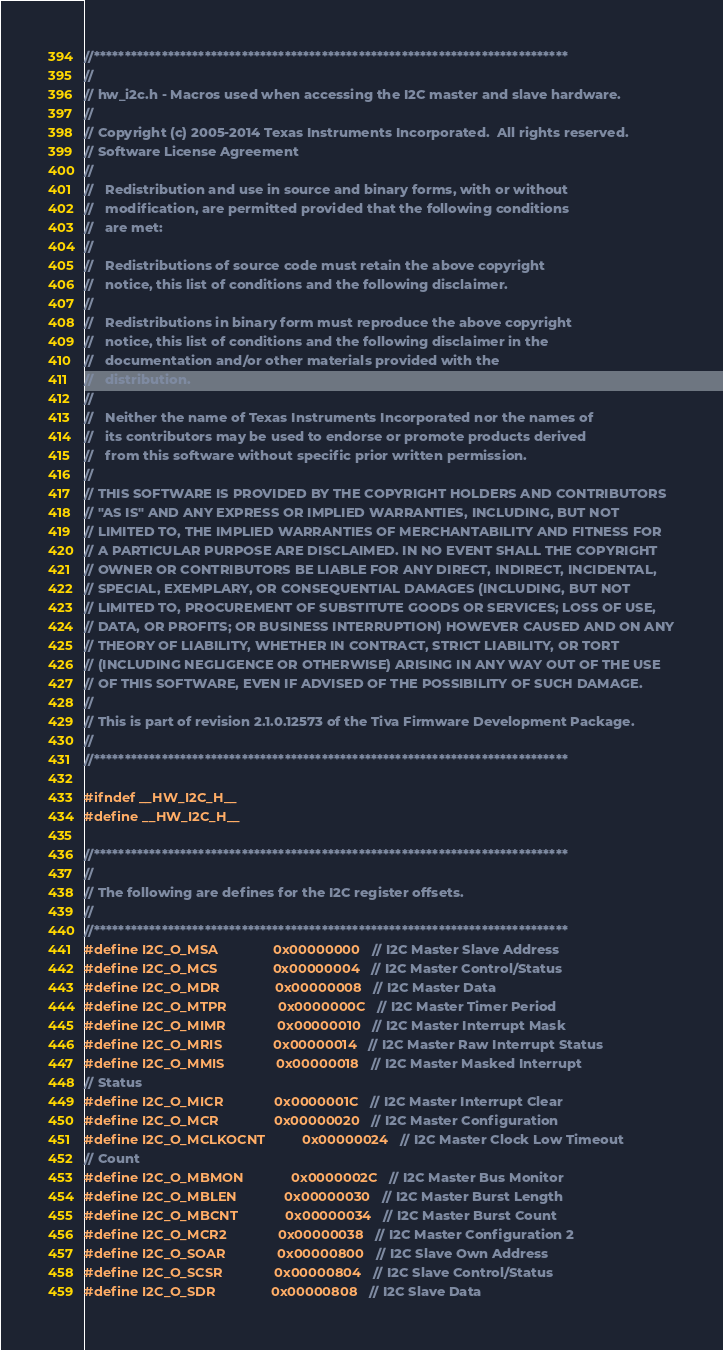<code> <loc_0><loc_0><loc_500><loc_500><_C_>//*****************************************************************************
//
// hw_i2c.h - Macros used when accessing the I2C master and slave hardware.
//
// Copyright (c) 2005-2014 Texas Instruments Incorporated.  All rights reserved.
// Software License Agreement
//
//   Redistribution and use in source and binary forms, with or without
//   modification, are permitted provided that the following conditions
//   are met:
//
//   Redistributions of source code must retain the above copyright
//   notice, this list of conditions and the following disclaimer.
//
//   Redistributions in binary form must reproduce the above copyright
//   notice, this list of conditions and the following disclaimer in the
//   documentation and/or other materials provided with the
//   distribution.
//
//   Neither the name of Texas Instruments Incorporated nor the names of
//   its contributors may be used to endorse or promote products derived
//   from this software without specific prior written permission.
//
// THIS SOFTWARE IS PROVIDED BY THE COPYRIGHT HOLDERS AND CONTRIBUTORS
// "AS IS" AND ANY EXPRESS OR IMPLIED WARRANTIES, INCLUDING, BUT NOT
// LIMITED TO, THE IMPLIED WARRANTIES OF MERCHANTABILITY AND FITNESS FOR
// A PARTICULAR PURPOSE ARE DISCLAIMED. IN NO EVENT SHALL THE COPYRIGHT
// OWNER OR CONTRIBUTORS BE LIABLE FOR ANY DIRECT, INDIRECT, INCIDENTAL,
// SPECIAL, EXEMPLARY, OR CONSEQUENTIAL DAMAGES (INCLUDING, BUT NOT
// LIMITED TO, PROCUREMENT OF SUBSTITUTE GOODS OR SERVICES; LOSS OF USE,
// DATA, OR PROFITS; OR BUSINESS INTERRUPTION) HOWEVER CAUSED AND ON ANY
// THEORY OF LIABILITY, WHETHER IN CONTRACT, STRICT LIABILITY, OR TORT
// (INCLUDING NEGLIGENCE OR OTHERWISE) ARISING IN ANY WAY OUT OF THE USE
// OF THIS SOFTWARE, EVEN IF ADVISED OF THE POSSIBILITY OF SUCH DAMAGE.
//
// This is part of revision 2.1.0.12573 of the Tiva Firmware Development Package.
//
//*****************************************************************************

#ifndef __HW_I2C_H__
#define __HW_I2C_H__

//*****************************************************************************
//
// The following are defines for the I2C register offsets.
//
//*****************************************************************************
#define I2C_O_MSA               0x00000000  // I2C Master Slave Address
#define I2C_O_MCS               0x00000004  // I2C Master Control/Status
#define I2C_O_MDR               0x00000008  // I2C Master Data
#define I2C_O_MTPR              0x0000000C  // I2C Master Timer Period
#define I2C_O_MIMR              0x00000010  // I2C Master Interrupt Mask
#define I2C_O_MRIS              0x00000014  // I2C Master Raw Interrupt Status
#define I2C_O_MMIS              0x00000018  // I2C Master Masked Interrupt
// Status
#define I2C_O_MICR              0x0000001C  // I2C Master Interrupt Clear
#define I2C_O_MCR               0x00000020  // I2C Master Configuration
#define I2C_O_MCLKOCNT          0x00000024  // I2C Master Clock Low Timeout
// Count
#define I2C_O_MBMON             0x0000002C  // I2C Master Bus Monitor
#define I2C_O_MBLEN             0x00000030  // I2C Master Burst Length
#define I2C_O_MBCNT             0x00000034  // I2C Master Burst Count
#define I2C_O_MCR2              0x00000038  // I2C Master Configuration 2
#define I2C_O_SOAR              0x00000800  // I2C Slave Own Address
#define I2C_O_SCSR              0x00000804  // I2C Slave Control/Status
#define I2C_O_SDR               0x00000808  // I2C Slave Data</code> 